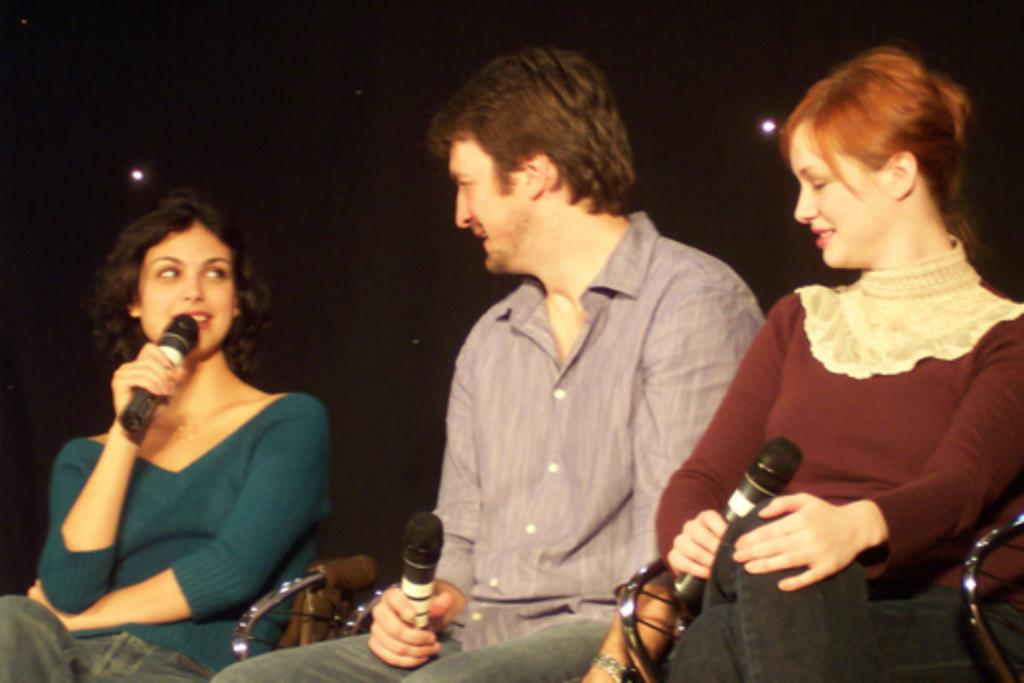How many people are in the image? There are three people in the image: a man and two women. What are the people in the image doing? The man and women are sitting on chairs and holding microphones in their hands. Is one of the women speaking in the image? Yes, one of the women is speaking in the image. What is the color of the background in the image? The background of the image is dark. What type of oatmeal is being served on the table in the image? There is no table or oatmeal present in the image. Can you tell me how many pairs of scissors are visible in the image? There are no scissors visible in the image. 